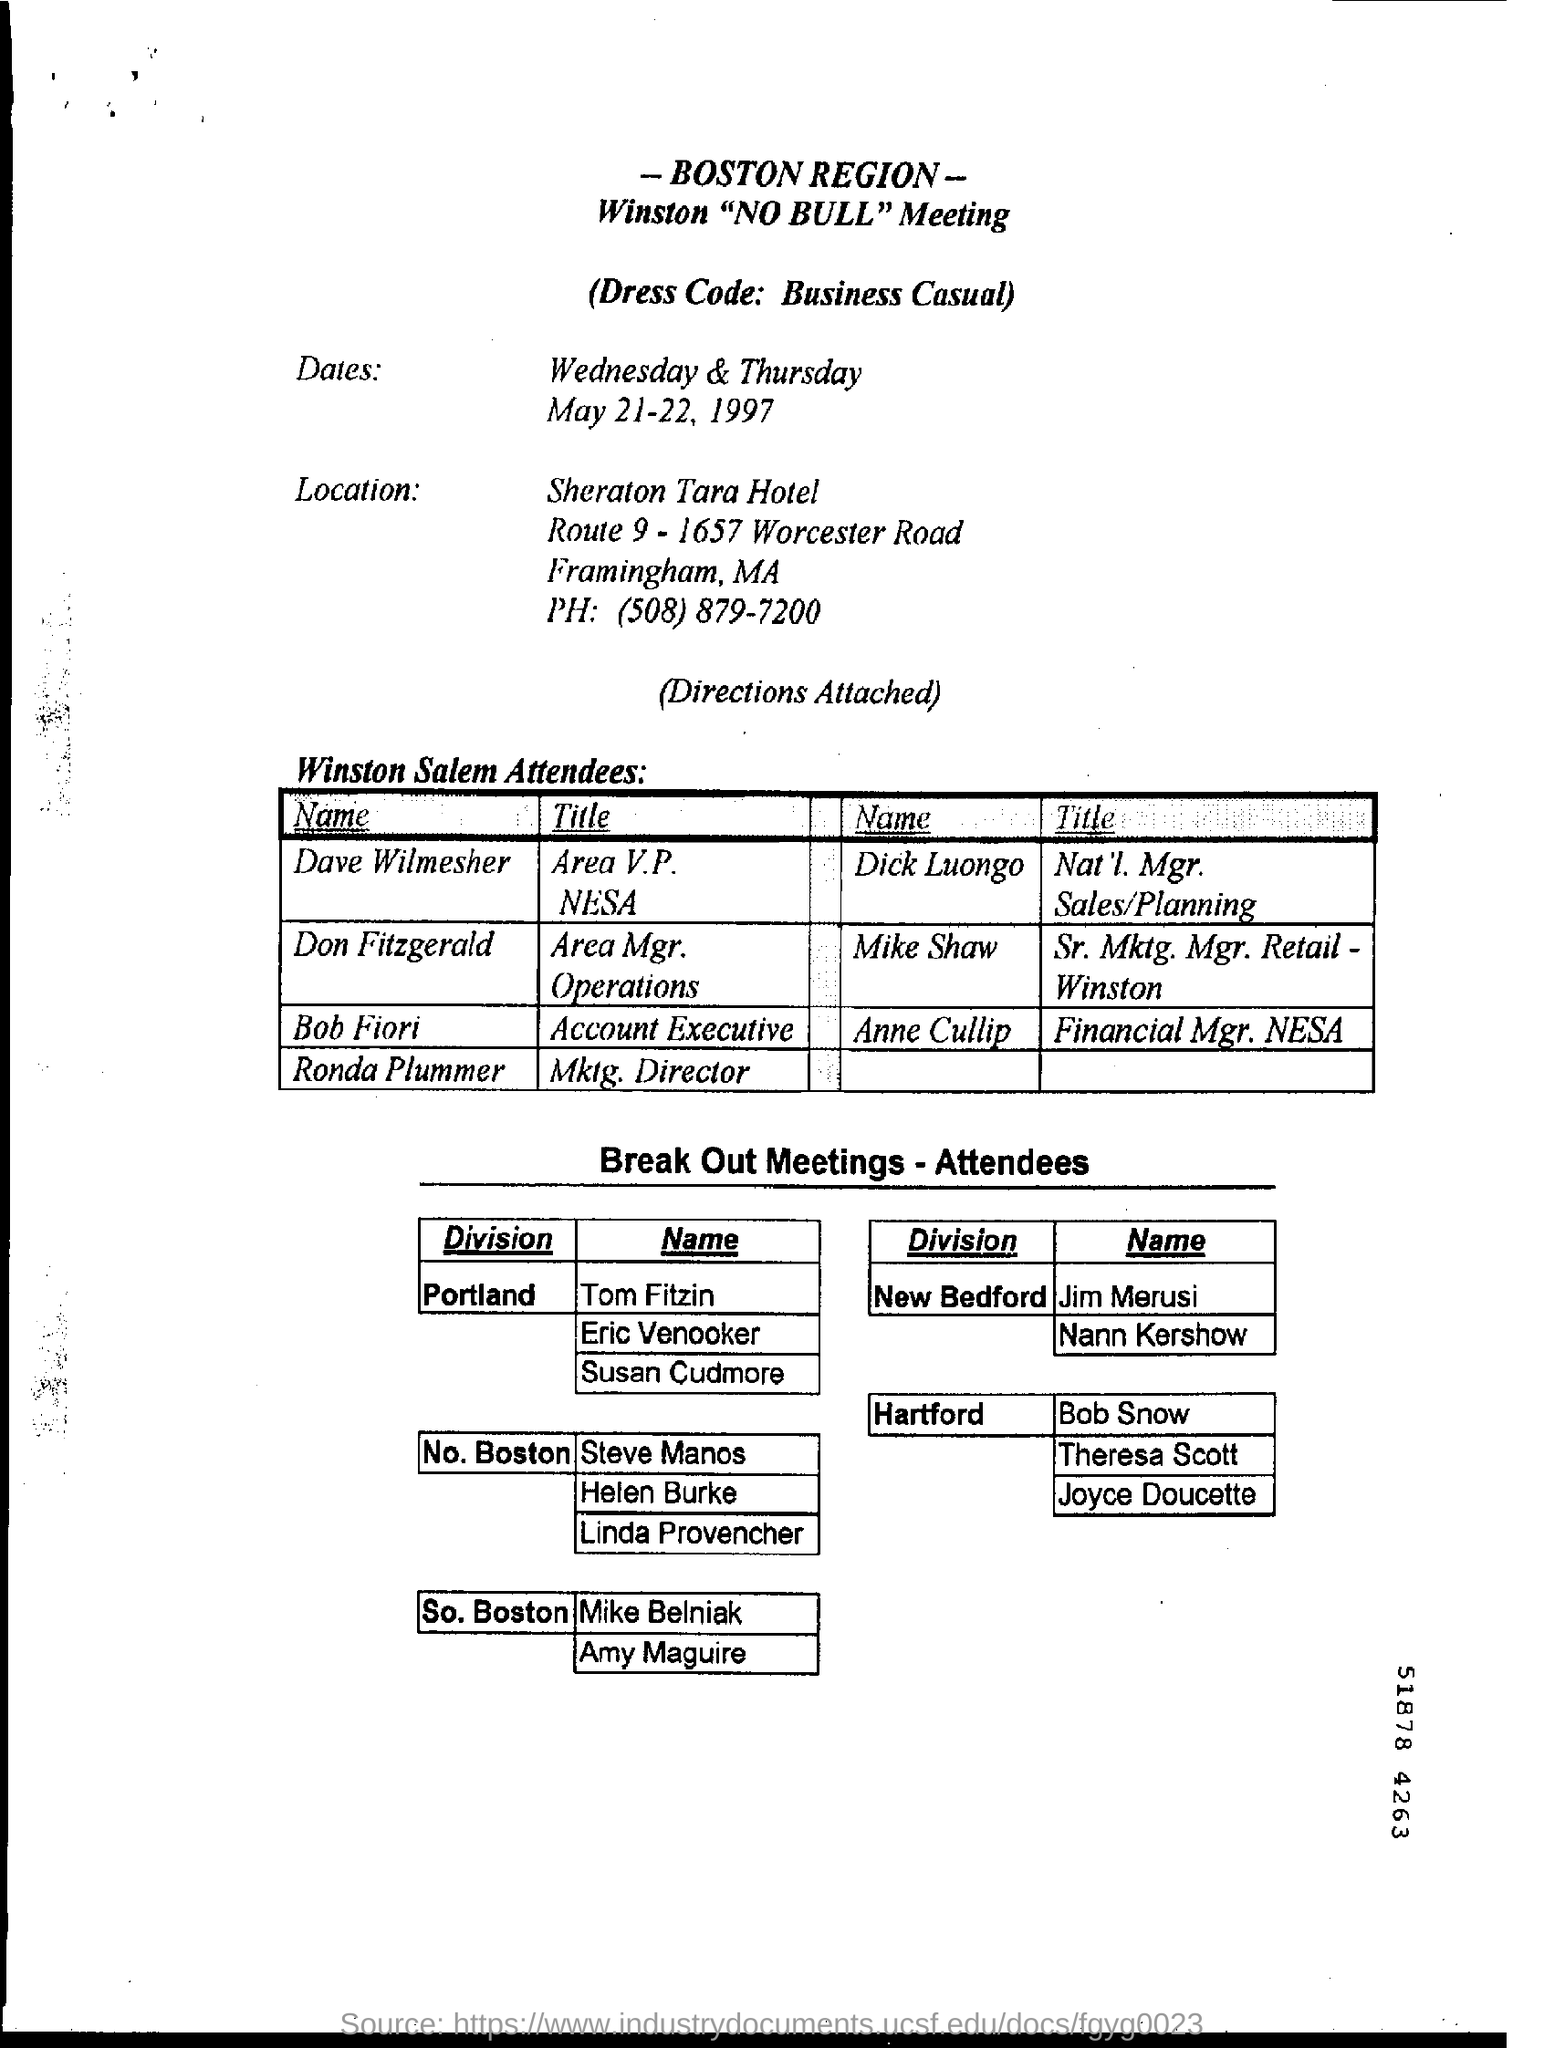Highlight a few significant elements in this photo. The dress code for the meeting is business casual. The digit shown at the bottom right corner of the number 51878 is 8. 